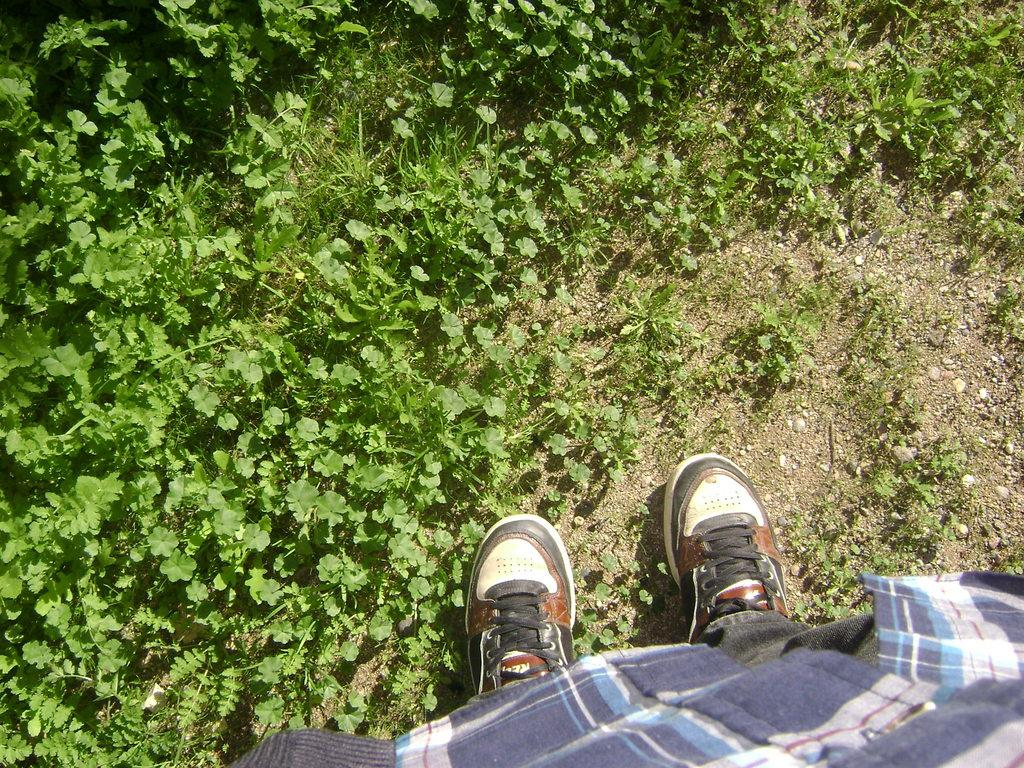What body parts and clothing can be seen in the image? Legs and shoes are visible in the image. What type of natural environment is present in the background of the image? There is grass in the background of the image. What type of dress is the plane wearing in the image? There is no plane present in the image, and therefore no dress or plane can be observed. 